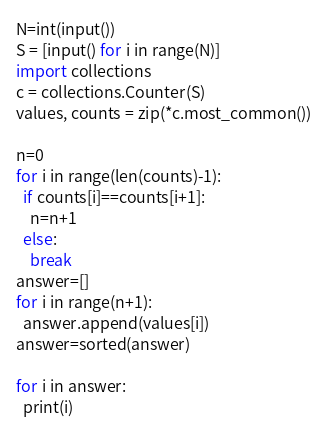<code> <loc_0><loc_0><loc_500><loc_500><_Python_>N=int(input())
S = [input() for i in range(N)]
import collections
c = collections.Counter(S)
values, counts = zip(*c.most_common())

n=0
for i in range(len(counts)-1):
  if counts[i]==counts[i+1]:
    n=n+1
  else:
    break
answer=[]    
for i in range(n+1):
  answer.append(values[i])
answer=sorted(answer)

for i in answer:
  print(i)
</code> 